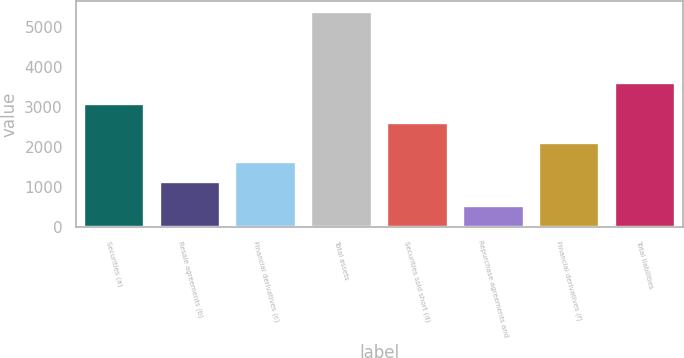Convert chart. <chart><loc_0><loc_0><loc_500><loc_500><bar_chart><fcel>Securities (a)<fcel>Resale agreements (b)<fcel>Financial derivatives (c)<fcel>Total assets<fcel>Securities sold short (d)<fcel>Repurchase agreements and<fcel>Financial derivatives (f)<fcel>Total liabilities<nl><fcel>3079<fcel>1133<fcel>1619.5<fcel>5385<fcel>2592.5<fcel>520<fcel>2106<fcel>3600<nl></chart> 